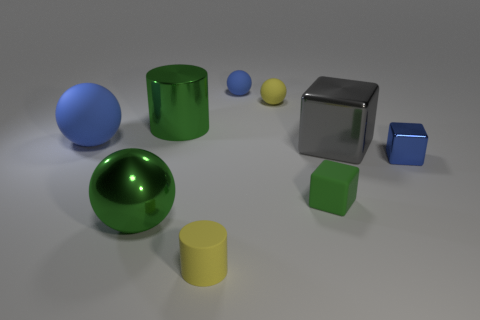Subtract all green shiny balls. How many balls are left? 3 Subtract all cyan blocks. How many blue balls are left? 2 Add 1 big gray metallic objects. How many objects exist? 10 Subtract all yellow spheres. How many spheres are left? 3 Subtract all cubes. How many objects are left? 6 Subtract 1 blocks. How many blocks are left? 2 Subtract all cyan cylinders. Subtract all purple spheres. How many cylinders are left? 2 Subtract all small cylinders. Subtract all big blue things. How many objects are left? 7 Add 4 big blue matte things. How many big blue matte things are left? 5 Add 3 green rubber things. How many green rubber things exist? 4 